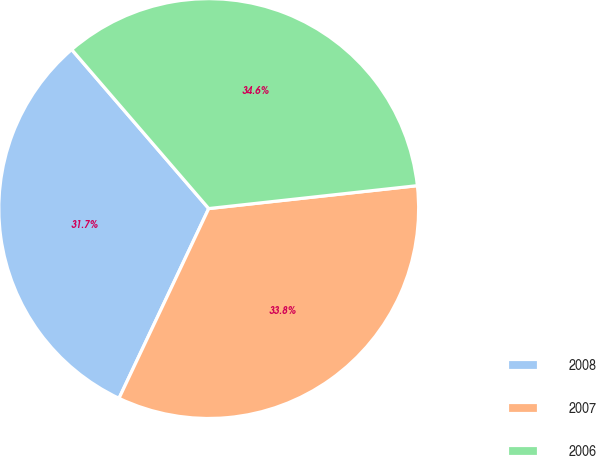<chart> <loc_0><loc_0><loc_500><loc_500><pie_chart><fcel>2008<fcel>2007<fcel>2006<nl><fcel>31.65%<fcel>33.77%<fcel>34.58%<nl></chart> 